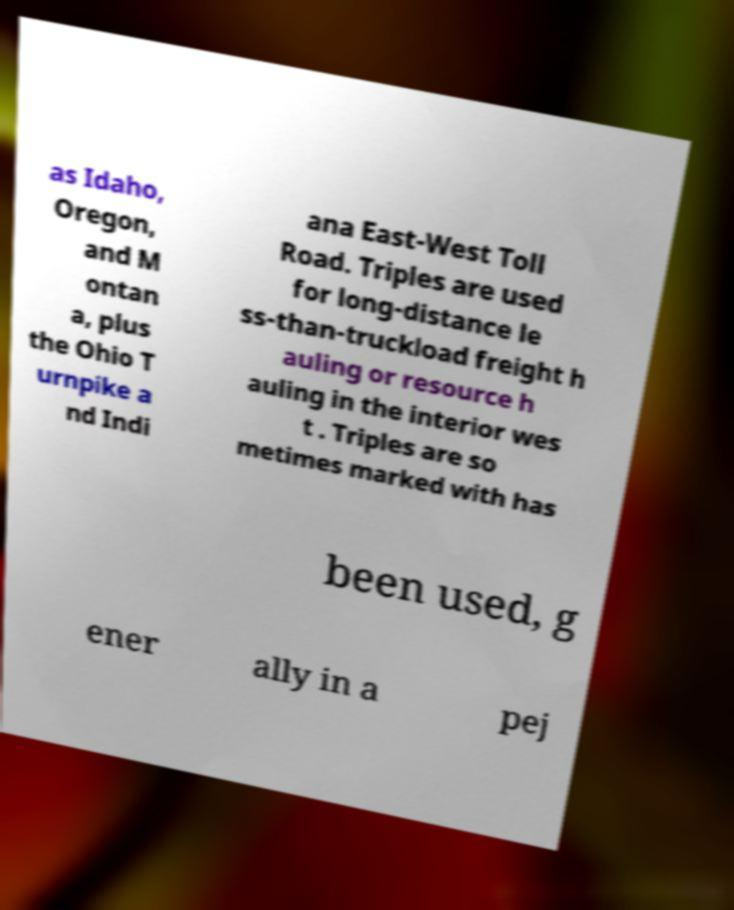There's text embedded in this image that I need extracted. Can you transcribe it verbatim? as Idaho, Oregon, and M ontan a, plus the Ohio T urnpike a nd Indi ana East-West Toll Road. Triples are used for long-distance le ss-than-truckload freight h auling or resource h auling in the interior wes t . Triples are so metimes marked with has been used, g ener ally in a pej 